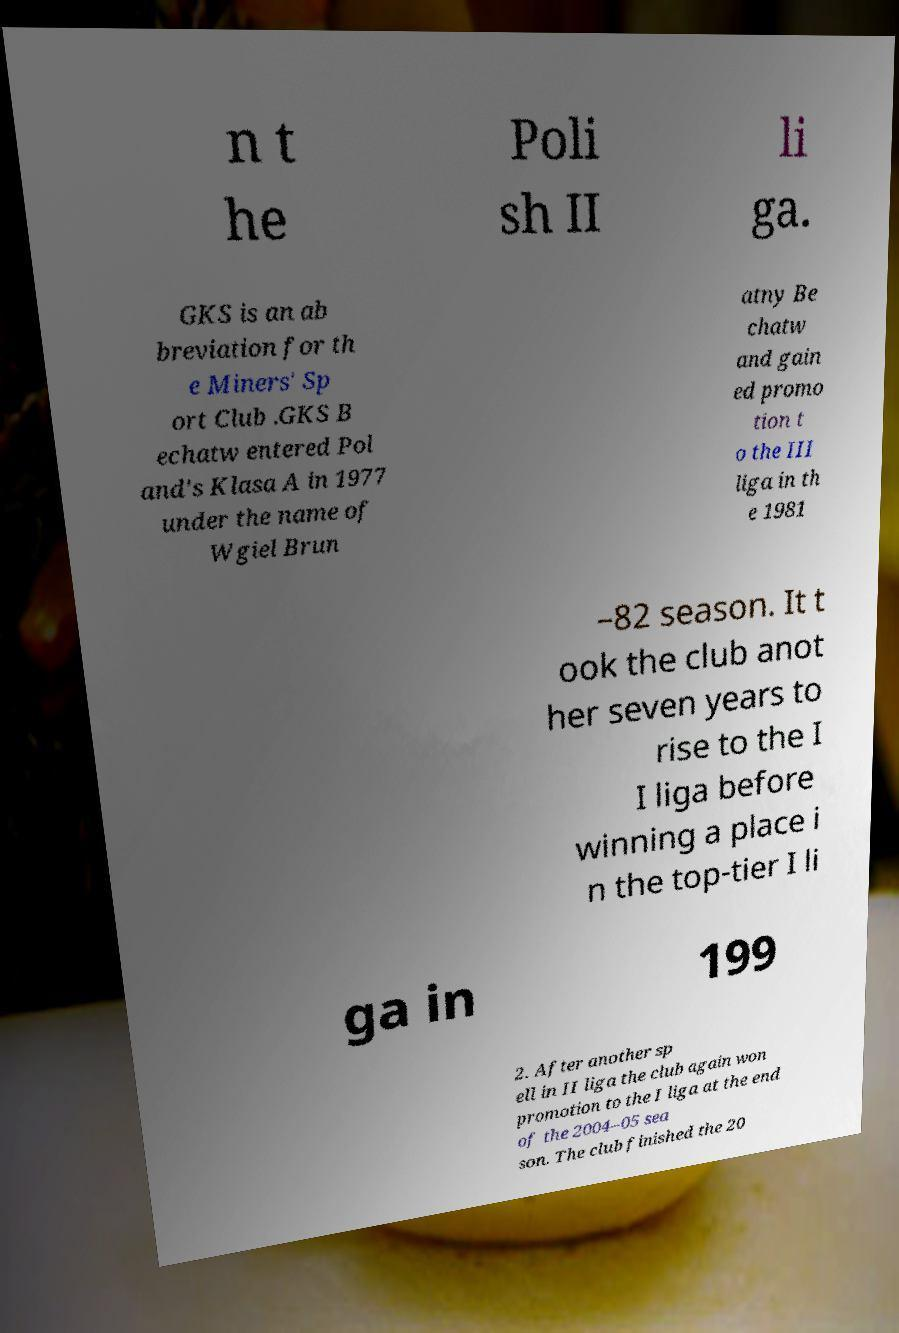Can you read and provide the text displayed in the image?This photo seems to have some interesting text. Can you extract and type it out for me? n t he Poli sh II li ga. GKS is an ab breviation for th e Miners' Sp ort Club .GKS B echatw entered Pol and's Klasa A in 1977 under the name of Wgiel Brun atny Be chatw and gain ed promo tion t o the III liga in th e 1981 –82 season. It t ook the club anot her seven years to rise to the I I liga before winning a place i n the top-tier I li ga in 199 2. After another sp ell in II liga the club again won promotion to the I liga at the end of the 2004–05 sea son. The club finished the 20 